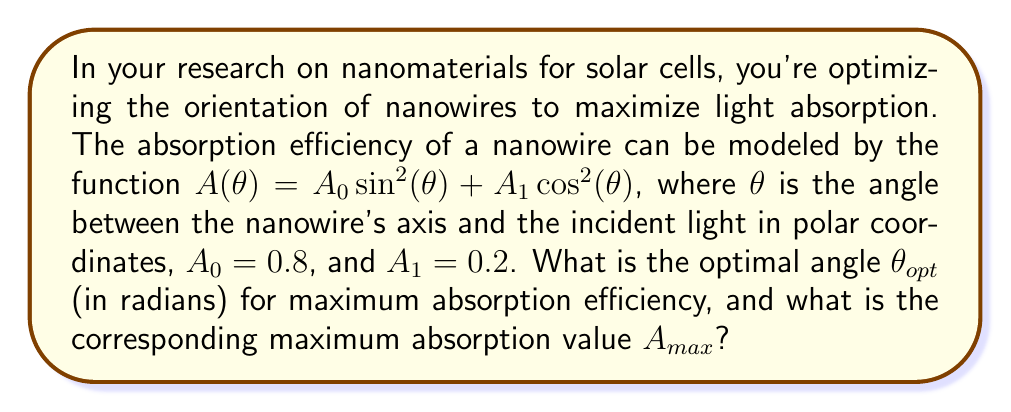Solve this math problem. To solve this problem, we'll follow these steps:

1) The absorption function is given by:
   $$A(\theta) = A_0 \sin^2(\theta) + A_1 \cos^2(\theta)$$
   where $A_0 = 0.8$ and $A_1 = 0.2$

2) To find the maximum, we need to differentiate $A(\theta)$ with respect to $\theta$ and set it to zero:
   $$\frac{dA}{d\theta} = 2A_0 \sin(\theta)\cos(\theta) - 2A_1 \cos(\theta)\sin(\theta) = 0$$

3) Simplify:
   $$2\sin(\theta)\cos(\theta)(A_0 - A_1) = 0$$

4) This equation is satisfied when either $\sin(\theta) = 0$, $\cos(\theta) = 0$, or $A_0 = A_1$. Since $A_0 \neq A_1$, we focus on the trigonometric solutions.

5) $\sin(\theta) = 0$ occurs at $\theta = 0, \pi, 2\pi, ...$
   $\cos(\theta) = 0$ occurs at $\theta = \frac{\pi}{2}, \frac{3\pi}{2}, ...$

6) To determine which of these is the maximum, we can check the second derivative:
   $$\frac{d^2A}{d\theta^2} = 2(A_0 - A_1)(\cos^2(\theta) - \sin^2(\theta))$$

7) At $\theta = \frac{\pi}{2}$, $\frac{d^2A}{d\theta^2} < 0$ (since $A_0 > A_1$), indicating a maximum.

8) Therefore, the optimal angle is $\theta_{opt} = \frac{\pi}{2}$ radians.

9) The maximum absorption value is:
   $$A_{max} = A(\frac{\pi}{2}) = A_0 \sin^2(\frac{\pi}{2}) + A_1 \cos^2(\frac{\pi}{2}) = A_0 = 0.8$$
Answer: The optimal angle is $\theta_{opt} = \frac{\pi}{2}$ radians, and the maximum absorption value is $A_{max} = 0.8$. 